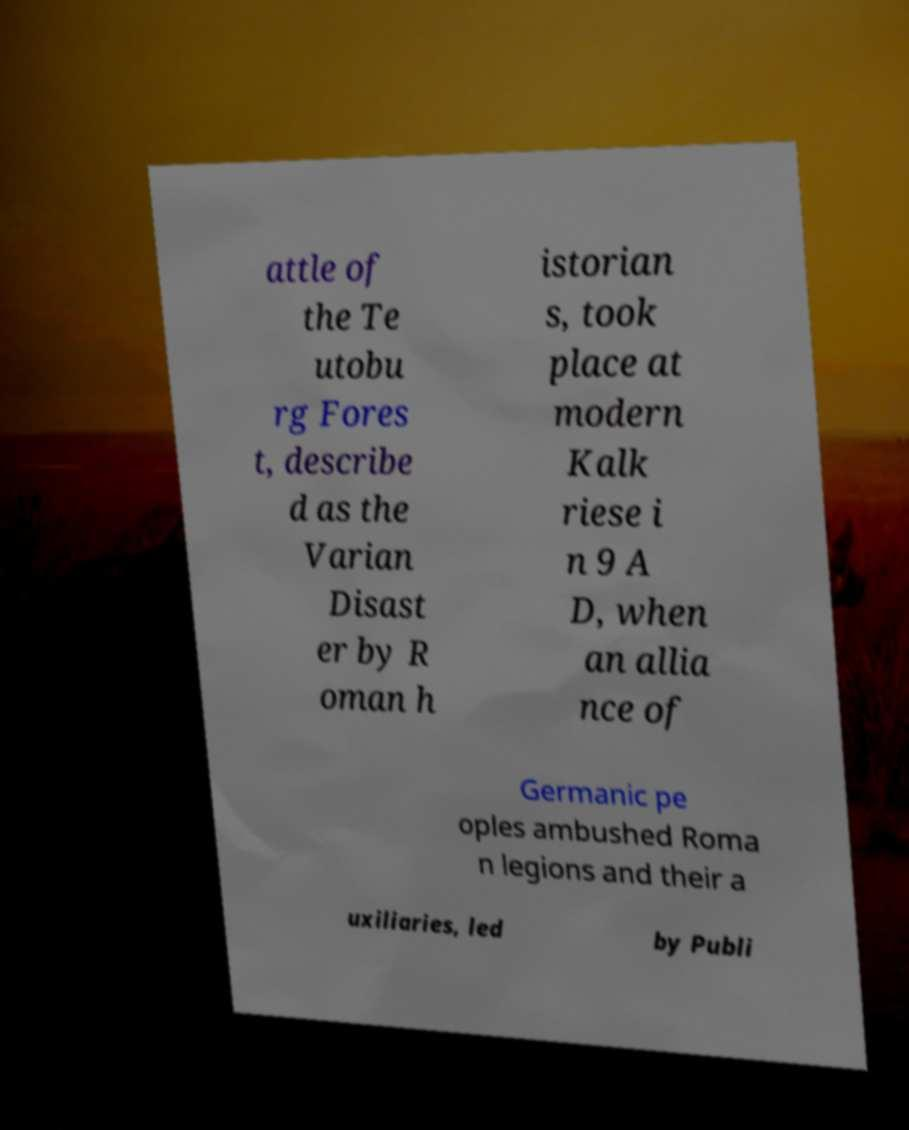For documentation purposes, I need the text within this image transcribed. Could you provide that? attle of the Te utobu rg Fores t, describe d as the Varian Disast er by R oman h istorian s, took place at modern Kalk riese i n 9 A D, when an allia nce of Germanic pe oples ambushed Roma n legions and their a uxiliaries, led by Publi 